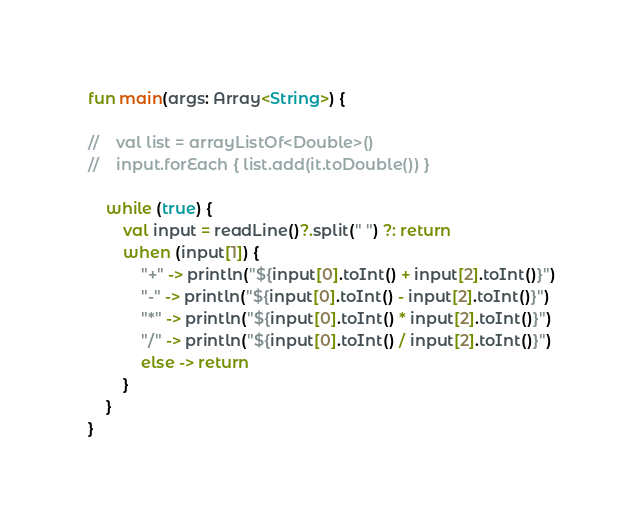<code> <loc_0><loc_0><loc_500><loc_500><_Kotlin_>
fun main(args: Array<String>) {

//    val list = arrayListOf<Double>()
//    input.forEach { list.add(it.toDouble()) }

    while (true) {
        val input = readLine()?.split(" ") ?: return
        when (input[1]) {
            "+" -> println("${input[0].toInt() + input[2].toInt()}")
            "-" -> println("${input[0].toInt() - input[2].toInt()}")
            "*" -> println("${input[0].toInt() * input[2].toInt()}")
            "/" -> println("${input[0].toInt() / input[2].toInt()}")
            else -> return
        }
    }
}

</code> 